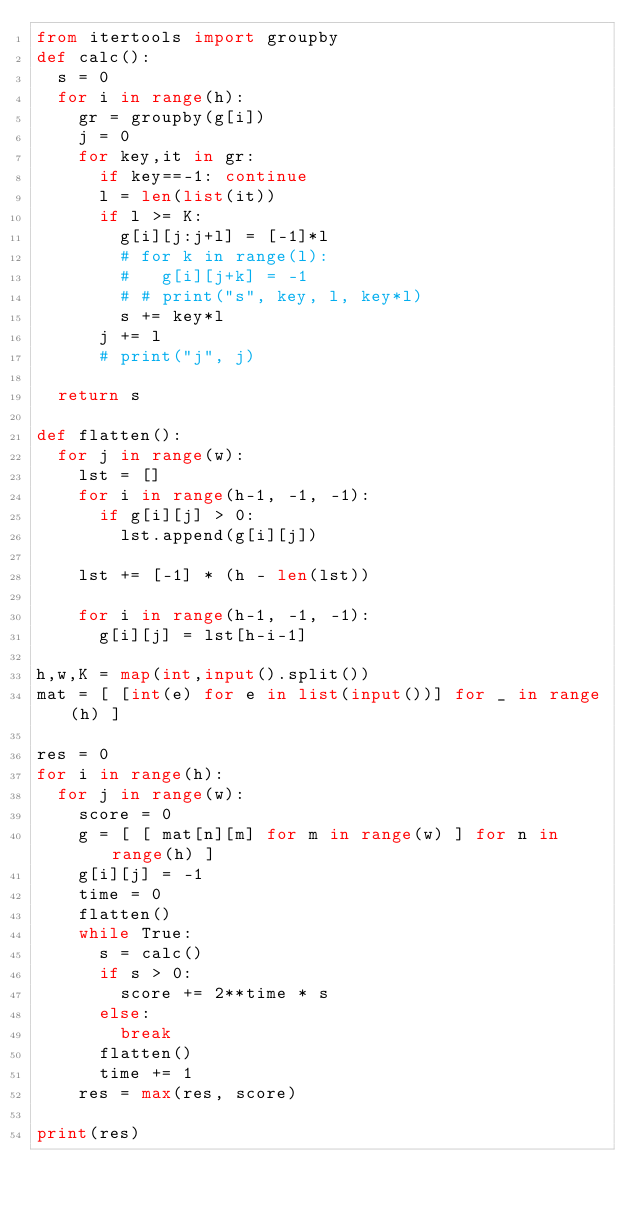<code> <loc_0><loc_0><loc_500><loc_500><_Python_>from itertools import groupby
def calc():
  s = 0
  for i in range(h):
    gr = groupby(g[i])
    j = 0
    for key,it in gr:
      if key==-1: continue
      l = len(list(it))
      if l >= K:
        g[i][j:j+l] = [-1]*l
        # for k in range(l):
        #   g[i][j+k] = -1
        # # print("s", key, l, key*l)
        s += key*l
      j += l
      # print("j", j)

  return s

def flatten():
  for j in range(w):
    lst = []
    for i in range(h-1, -1, -1):
      if g[i][j] > 0:
        lst.append(g[i][j])

    lst += [-1] * (h - len(lst))

    for i in range(h-1, -1, -1):
      g[i][j] = lst[h-i-1]

h,w,K = map(int,input().split())
mat = [ [int(e) for e in list(input())] for _ in range(h) ]

res = 0
for i in range(h):
  for j in range(w):
    score = 0
    g = [ [ mat[n][m] for m in range(w) ] for n in range(h) ]
    g[i][j] = -1
    time = 0
    flatten()
    while True:
      s = calc()
      if s > 0:
        score += 2**time * s
      else:
        break
      flatten()
      time += 1
    res = max(res, score)

print(res)</code> 